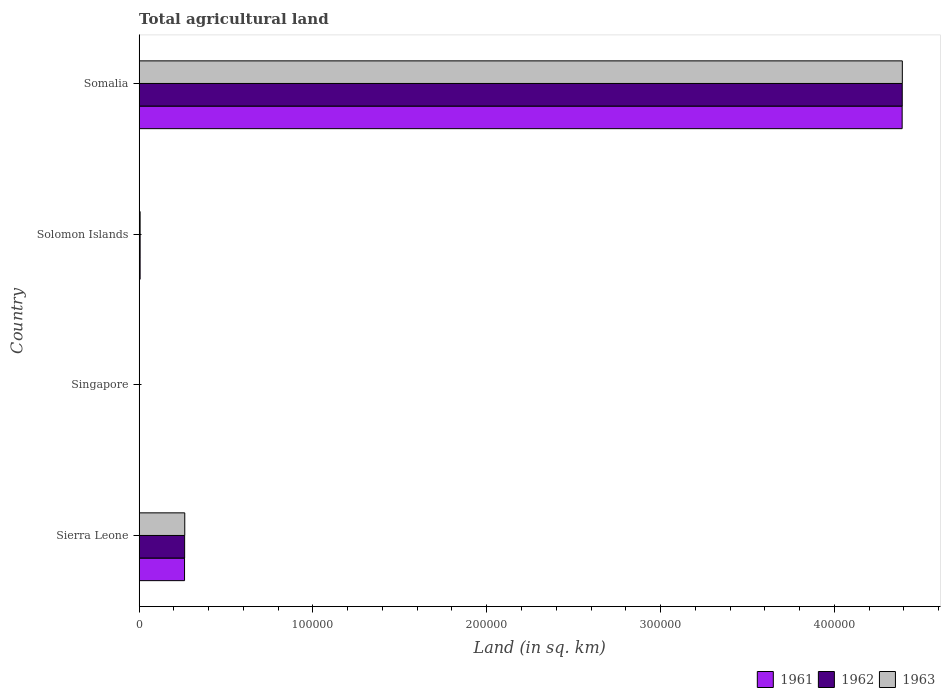How many different coloured bars are there?
Your answer should be compact. 3. How many groups of bars are there?
Make the answer very short. 4. Are the number of bars on each tick of the Y-axis equal?
Offer a very short reply. Yes. What is the label of the 2nd group of bars from the top?
Provide a succinct answer. Solomon Islands. What is the total agricultural land in 1963 in Somalia?
Ensure brevity in your answer.  4.39e+05. Across all countries, what is the maximum total agricultural land in 1962?
Provide a succinct answer. 4.39e+05. Across all countries, what is the minimum total agricultural land in 1961?
Provide a succinct answer. 140. In which country was the total agricultural land in 1961 maximum?
Your response must be concise. Somalia. In which country was the total agricultural land in 1961 minimum?
Provide a succinct answer. Singapore. What is the total total agricultural land in 1962 in the graph?
Provide a short and direct response. 4.66e+05. What is the difference between the total agricultural land in 1962 in Sierra Leone and that in Solomon Islands?
Offer a very short reply. 2.56e+04. What is the difference between the total agricultural land in 1962 in Sierra Leone and the total agricultural land in 1961 in Singapore?
Provide a short and direct response. 2.60e+04. What is the average total agricultural land in 1963 per country?
Offer a terse response. 1.17e+05. What is the difference between the total agricultural land in 1961 and total agricultural land in 1963 in Solomon Islands?
Give a very brief answer. 0. What is the ratio of the total agricultural land in 1962 in Solomon Islands to that in Somalia?
Keep it short and to the point. 0. Is the difference between the total agricultural land in 1961 in Sierra Leone and Singapore greater than the difference between the total agricultural land in 1963 in Sierra Leone and Singapore?
Your answer should be compact. No. What is the difference between the highest and the second highest total agricultural land in 1962?
Give a very brief answer. 4.13e+05. What is the difference between the highest and the lowest total agricultural land in 1963?
Keep it short and to the point. 4.39e+05. Is the sum of the total agricultural land in 1961 in Singapore and Solomon Islands greater than the maximum total agricultural land in 1963 across all countries?
Your answer should be compact. No. What does the 1st bar from the bottom in Sierra Leone represents?
Give a very brief answer. 1961. Is it the case that in every country, the sum of the total agricultural land in 1963 and total agricultural land in 1962 is greater than the total agricultural land in 1961?
Provide a short and direct response. Yes. What is the difference between two consecutive major ticks on the X-axis?
Offer a terse response. 1.00e+05. Are the values on the major ticks of X-axis written in scientific E-notation?
Your answer should be very brief. No. Where does the legend appear in the graph?
Your answer should be compact. Bottom right. How many legend labels are there?
Your answer should be compact. 3. What is the title of the graph?
Make the answer very short. Total agricultural land. Does "1970" appear as one of the legend labels in the graph?
Provide a succinct answer. No. What is the label or title of the X-axis?
Your answer should be compact. Land (in sq. km). What is the Land (in sq. km) in 1961 in Sierra Leone?
Your answer should be compact. 2.61e+04. What is the Land (in sq. km) in 1962 in Sierra Leone?
Your response must be concise. 2.62e+04. What is the Land (in sq. km) in 1963 in Sierra Leone?
Offer a very short reply. 2.62e+04. What is the Land (in sq. km) of 1961 in Singapore?
Keep it short and to the point. 140. What is the Land (in sq. km) in 1962 in Singapore?
Offer a terse response. 140. What is the Land (in sq. km) of 1963 in Singapore?
Offer a terse response. 130. What is the Land (in sq. km) of 1961 in Solomon Islands?
Your response must be concise. 550. What is the Land (in sq. km) in 1962 in Solomon Islands?
Offer a terse response. 550. What is the Land (in sq. km) in 1963 in Solomon Islands?
Ensure brevity in your answer.  550. What is the Land (in sq. km) of 1961 in Somalia?
Give a very brief answer. 4.39e+05. What is the Land (in sq. km) of 1962 in Somalia?
Provide a short and direct response. 4.39e+05. What is the Land (in sq. km) of 1963 in Somalia?
Offer a terse response. 4.39e+05. Across all countries, what is the maximum Land (in sq. km) in 1961?
Offer a terse response. 4.39e+05. Across all countries, what is the maximum Land (in sq. km) of 1962?
Give a very brief answer. 4.39e+05. Across all countries, what is the maximum Land (in sq. km) of 1963?
Offer a very short reply. 4.39e+05. Across all countries, what is the minimum Land (in sq. km) in 1961?
Keep it short and to the point. 140. Across all countries, what is the minimum Land (in sq. km) in 1962?
Your answer should be very brief. 140. Across all countries, what is the minimum Land (in sq. km) of 1963?
Your response must be concise. 130. What is the total Land (in sq. km) in 1961 in the graph?
Keep it short and to the point. 4.66e+05. What is the total Land (in sq. km) in 1962 in the graph?
Your answer should be very brief. 4.66e+05. What is the total Land (in sq. km) of 1963 in the graph?
Give a very brief answer. 4.66e+05. What is the difference between the Land (in sq. km) in 1961 in Sierra Leone and that in Singapore?
Ensure brevity in your answer.  2.60e+04. What is the difference between the Land (in sq. km) of 1962 in Sierra Leone and that in Singapore?
Your response must be concise. 2.60e+04. What is the difference between the Land (in sq. km) in 1963 in Sierra Leone and that in Singapore?
Provide a succinct answer. 2.61e+04. What is the difference between the Land (in sq. km) of 1961 in Sierra Leone and that in Solomon Islands?
Keep it short and to the point. 2.56e+04. What is the difference between the Land (in sq. km) of 1962 in Sierra Leone and that in Solomon Islands?
Offer a terse response. 2.56e+04. What is the difference between the Land (in sq. km) of 1963 in Sierra Leone and that in Solomon Islands?
Your response must be concise. 2.57e+04. What is the difference between the Land (in sq. km) of 1961 in Sierra Leone and that in Somalia?
Give a very brief answer. -4.13e+05. What is the difference between the Land (in sq. km) of 1962 in Sierra Leone and that in Somalia?
Keep it short and to the point. -4.13e+05. What is the difference between the Land (in sq. km) of 1963 in Sierra Leone and that in Somalia?
Your answer should be compact. -4.13e+05. What is the difference between the Land (in sq. km) in 1961 in Singapore and that in Solomon Islands?
Your answer should be compact. -410. What is the difference between the Land (in sq. km) in 1962 in Singapore and that in Solomon Islands?
Keep it short and to the point. -410. What is the difference between the Land (in sq. km) of 1963 in Singapore and that in Solomon Islands?
Offer a very short reply. -420. What is the difference between the Land (in sq. km) of 1961 in Singapore and that in Somalia?
Keep it short and to the point. -4.39e+05. What is the difference between the Land (in sq. km) of 1962 in Singapore and that in Somalia?
Make the answer very short. -4.39e+05. What is the difference between the Land (in sq. km) in 1963 in Singapore and that in Somalia?
Make the answer very short. -4.39e+05. What is the difference between the Land (in sq. km) of 1961 in Solomon Islands and that in Somalia?
Offer a terse response. -4.38e+05. What is the difference between the Land (in sq. km) of 1962 in Solomon Islands and that in Somalia?
Your answer should be compact. -4.39e+05. What is the difference between the Land (in sq. km) of 1963 in Solomon Islands and that in Somalia?
Give a very brief answer. -4.39e+05. What is the difference between the Land (in sq. km) in 1961 in Sierra Leone and the Land (in sq. km) in 1962 in Singapore?
Keep it short and to the point. 2.60e+04. What is the difference between the Land (in sq. km) of 1961 in Sierra Leone and the Land (in sq. km) of 1963 in Singapore?
Your answer should be compact. 2.60e+04. What is the difference between the Land (in sq. km) of 1962 in Sierra Leone and the Land (in sq. km) of 1963 in Singapore?
Ensure brevity in your answer.  2.60e+04. What is the difference between the Land (in sq. km) in 1961 in Sierra Leone and the Land (in sq. km) in 1962 in Solomon Islands?
Keep it short and to the point. 2.56e+04. What is the difference between the Land (in sq. km) in 1961 in Sierra Leone and the Land (in sq. km) in 1963 in Solomon Islands?
Offer a very short reply. 2.56e+04. What is the difference between the Land (in sq. km) of 1962 in Sierra Leone and the Land (in sq. km) of 1963 in Solomon Islands?
Provide a short and direct response. 2.56e+04. What is the difference between the Land (in sq. km) of 1961 in Sierra Leone and the Land (in sq. km) of 1962 in Somalia?
Keep it short and to the point. -4.13e+05. What is the difference between the Land (in sq. km) of 1961 in Sierra Leone and the Land (in sq. km) of 1963 in Somalia?
Your answer should be very brief. -4.13e+05. What is the difference between the Land (in sq. km) of 1962 in Sierra Leone and the Land (in sq. km) of 1963 in Somalia?
Your answer should be compact. -4.13e+05. What is the difference between the Land (in sq. km) of 1961 in Singapore and the Land (in sq. km) of 1962 in Solomon Islands?
Your answer should be very brief. -410. What is the difference between the Land (in sq. km) of 1961 in Singapore and the Land (in sq. km) of 1963 in Solomon Islands?
Offer a very short reply. -410. What is the difference between the Land (in sq. km) of 1962 in Singapore and the Land (in sq. km) of 1963 in Solomon Islands?
Offer a terse response. -410. What is the difference between the Land (in sq. km) in 1961 in Singapore and the Land (in sq. km) in 1962 in Somalia?
Your answer should be very brief. -4.39e+05. What is the difference between the Land (in sq. km) of 1961 in Singapore and the Land (in sq. km) of 1963 in Somalia?
Provide a succinct answer. -4.39e+05. What is the difference between the Land (in sq. km) of 1962 in Singapore and the Land (in sq. km) of 1963 in Somalia?
Provide a succinct answer. -4.39e+05. What is the difference between the Land (in sq. km) of 1961 in Solomon Islands and the Land (in sq. km) of 1962 in Somalia?
Your response must be concise. -4.39e+05. What is the difference between the Land (in sq. km) of 1961 in Solomon Islands and the Land (in sq. km) of 1963 in Somalia?
Offer a very short reply. -4.39e+05. What is the difference between the Land (in sq. km) in 1962 in Solomon Islands and the Land (in sq. km) in 1963 in Somalia?
Provide a short and direct response. -4.39e+05. What is the average Land (in sq. km) in 1961 per country?
Keep it short and to the point. 1.16e+05. What is the average Land (in sq. km) in 1962 per country?
Provide a succinct answer. 1.16e+05. What is the average Land (in sq. km) in 1963 per country?
Give a very brief answer. 1.17e+05. What is the difference between the Land (in sq. km) in 1961 and Land (in sq. km) in 1962 in Sierra Leone?
Offer a very short reply. -50. What is the difference between the Land (in sq. km) of 1961 and Land (in sq. km) of 1963 in Sierra Leone?
Your answer should be very brief. -120. What is the difference between the Land (in sq. km) of 1962 and Land (in sq. km) of 1963 in Sierra Leone?
Provide a short and direct response. -70. What is the difference between the Land (in sq. km) in 1961 and Land (in sq. km) in 1962 in Singapore?
Your answer should be compact. 0. What is the difference between the Land (in sq. km) of 1961 and Land (in sq. km) of 1963 in Singapore?
Ensure brevity in your answer.  10. What is the difference between the Land (in sq. km) in 1962 and Land (in sq. km) in 1963 in Singapore?
Provide a short and direct response. 10. What is the difference between the Land (in sq. km) of 1961 and Land (in sq. km) of 1962 in Solomon Islands?
Offer a very short reply. 0. What is the difference between the Land (in sq. km) of 1961 and Land (in sq. km) of 1963 in Somalia?
Provide a succinct answer. -100. What is the ratio of the Land (in sq. km) of 1961 in Sierra Leone to that in Singapore?
Keep it short and to the point. 186.57. What is the ratio of the Land (in sq. km) of 1962 in Sierra Leone to that in Singapore?
Provide a short and direct response. 186.93. What is the ratio of the Land (in sq. km) in 1963 in Sierra Leone to that in Singapore?
Offer a terse response. 201.85. What is the ratio of the Land (in sq. km) of 1961 in Sierra Leone to that in Solomon Islands?
Ensure brevity in your answer.  47.49. What is the ratio of the Land (in sq. km) of 1962 in Sierra Leone to that in Solomon Islands?
Give a very brief answer. 47.58. What is the ratio of the Land (in sq. km) in 1963 in Sierra Leone to that in Solomon Islands?
Ensure brevity in your answer.  47.71. What is the ratio of the Land (in sq. km) in 1961 in Sierra Leone to that in Somalia?
Ensure brevity in your answer.  0.06. What is the ratio of the Land (in sq. km) of 1962 in Sierra Leone to that in Somalia?
Provide a succinct answer. 0.06. What is the ratio of the Land (in sq. km) of 1963 in Sierra Leone to that in Somalia?
Keep it short and to the point. 0.06. What is the ratio of the Land (in sq. km) in 1961 in Singapore to that in Solomon Islands?
Give a very brief answer. 0.25. What is the ratio of the Land (in sq. km) of 1962 in Singapore to that in Solomon Islands?
Your response must be concise. 0.25. What is the ratio of the Land (in sq. km) in 1963 in Singapore to that in Solomon Islands?
Offer a terse response. 0.24. What is the ratio of the Land (in sq. km) of 1963 in Singapore to that in Somalia?
Offer a terse response. 0. What is the ratio of the Land (in sq. km) in 1961 in Solomon Islands to that in Somalia?
Offer a very short reply. 0. What is the ratio of the Land (in sq. km) of 1962 in Solomon Islands to that in Somalia?
Provide a succinct answer. 0. What is the ratio of the Land (in sq. km) of 1963 in Solomon Islands to that in Somalia?
Offer a terse response. 0. What is the difference between the highest and the second highest Land (in sq. km) in 1961?
Offer a terse response. 4.13e+05. What is the difference between the highest and the second highest Land (in sq. km) in 1962?
Your response must be concise. 4.13e+05. What is the difference between the highest and the second highest Land (in sq. km) in 1963?
Your response must be concise. 4.13e+05. What is the difference between the highest and the lowest Land (in sq. km) of 1961?
Make the answer very short. 4.39e+05. What is the difference between the highest and the lowest Land (in sq. km) of 1962?
Keep it short and to the point. 4.39e+05. What is the difference between the highest and the lowest Land (in sq. km) of 1963?
Make the answer very short. 4.39e+05. 